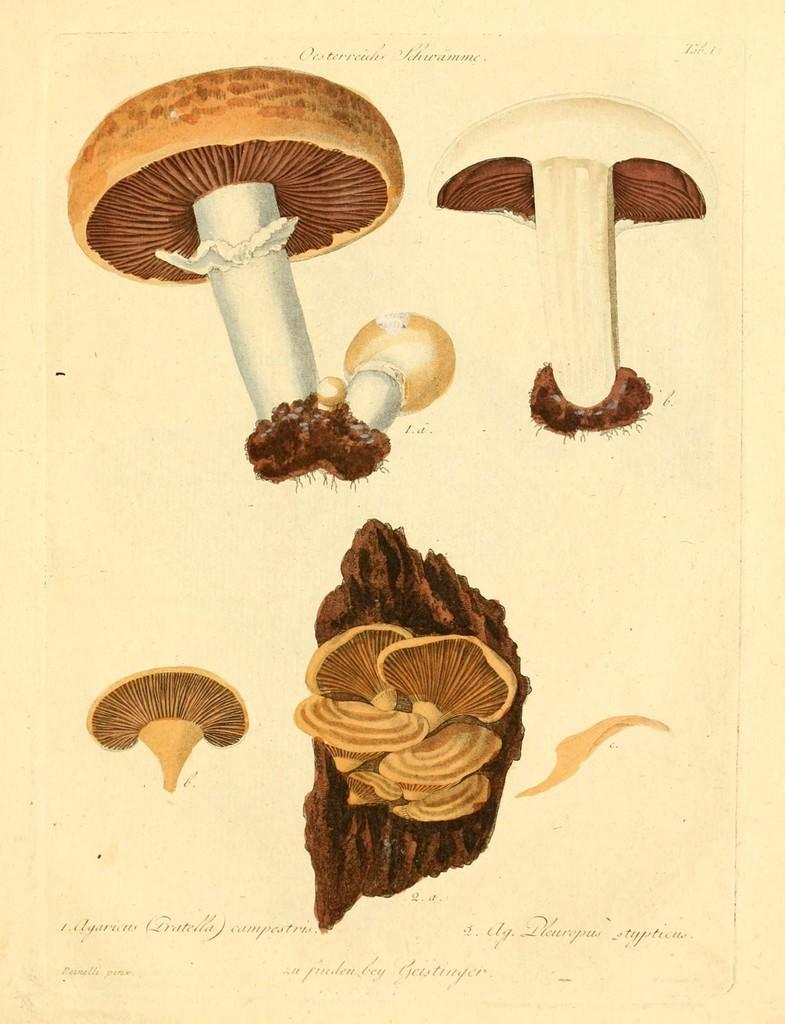How would you summarize this image in a sentence or two? This picture looks like a paper. In the paper we can see mushrooms, seeds and other objects. On the bottom we can see something is written. 